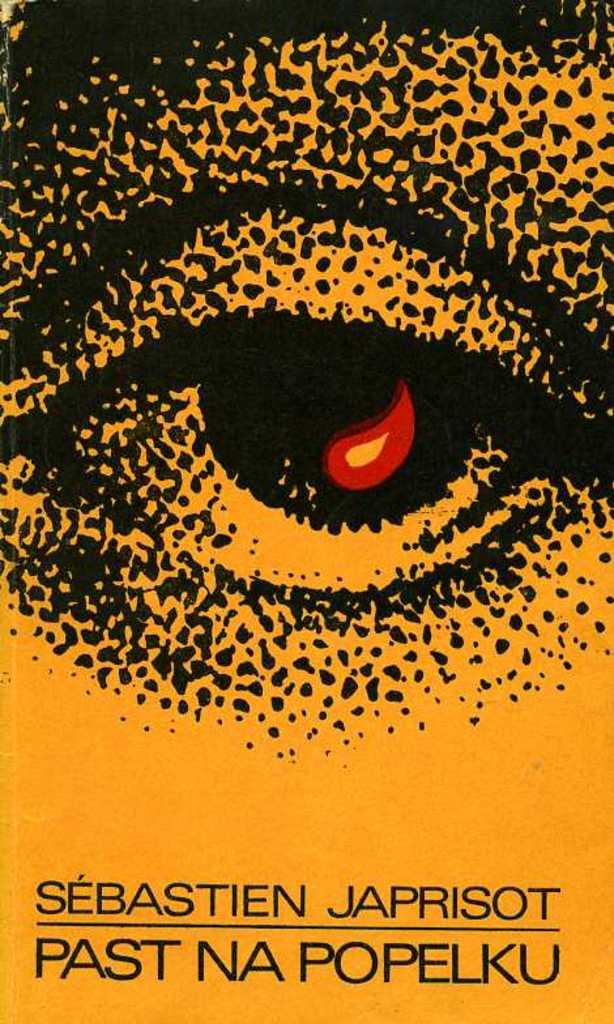<image>
Share a concise interpretation of the image provided. The cover for the book Past Na Popelku by Sebastian Japrisot. 